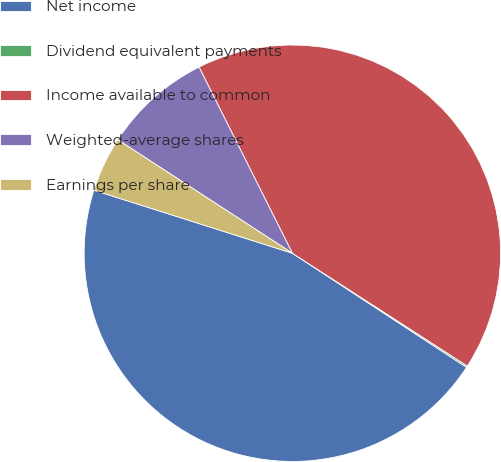Convert chart to OTSL. <chart><loc_0><loc_0><loc_500><loc_500><pie_chart><fcel>Net income<fcel>Dividend equivalent payments<fcel>Income available to common<fcel>Weighted-average shares<fcel>Earnings per share<nl><fcel>45.66%<fcel>0.12%<fcel>41.51%<fcel>8.43%<fcel>4.28%<nl></chart> 